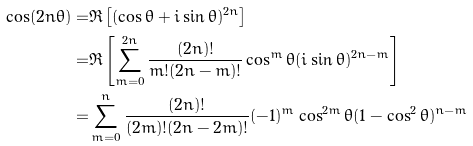Convert formula to latex. <formula><loc_0><loc_0><loc_500><loc_500>\cos ( 2 n \theta ) = & \Re \left [ ( \cos \theta + i \sin \theta ) ^ { 2 n } \right ] \\ = & \Re \left [ \sum _ { m = 0 } ^ { 2 n } \frac { ( 2 n ) ! } { m ! ( 2 n - m ) ! } \cos ^ { m } \theta ( i \sin \theta ) ^ { 2 n - m } \right ] \\ = & \sum _ { m = 0 } ^ { n } \frac { ( 2 n ) ! } { ( 2 m ) ! ( 2 n - 2 m ) ! } ( - 1 ) ^ { m } \cos ^ { 2 m } \theta ( 1 - \cos ^ { 2 } \theta ) ^ { n - m }</formula> 